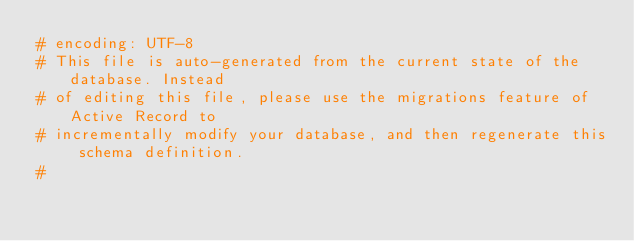<code> <loc_0><loc_0><loc_500><loc_500><_Ruby_># encoding: UTF-8
# This file is auto-generated from the current state of the database. Instead
# of editing this file, please use the migrations feature of Active Record to
# incrementally modify your database, and then regenerate this schema definition.
#</code> 